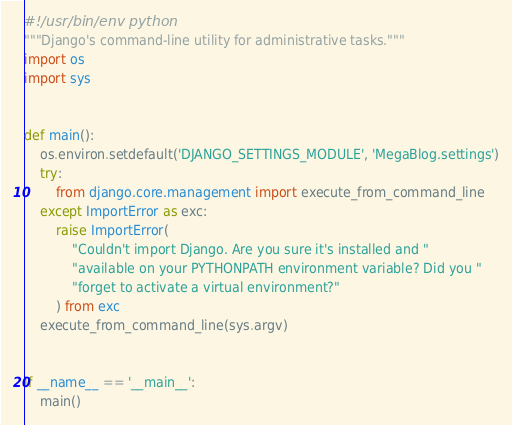Convert code to text. <code><loc_0><loc_0><loc_500><loc_500><_Python_>#!/usr/bin/env python
"""Django's command-line utility for administrative tasks."""
import os
import sys


def main():
    os.environ.setdefault('DJANGO_SETTINGS_MODULE', 'MegaBlog.settings')
    try:
        from django.core.management import execute_from_command_line
    except ImportError as exc:
        raise ImportError(
            "Couldn't import Django. Are you sure it's installed and "
            "available on your PYTHONPATH environment variable? Did you "
            "forget to activate a virtual environment?"
        ) from exc
    execute_from_command_line(sys.argv)


if __name__ == '__main__':
    main()
</code> 